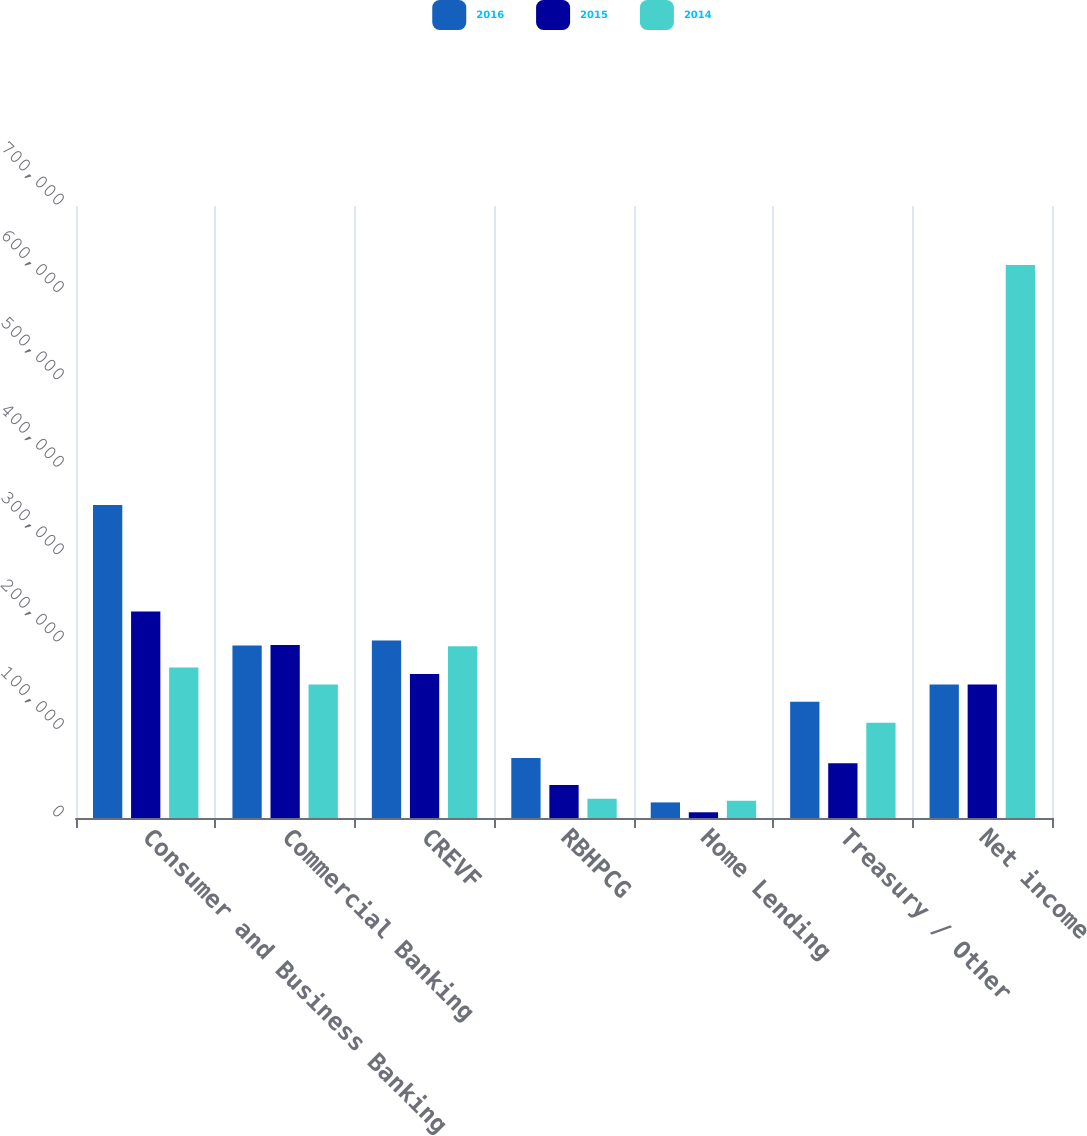Convert chart to OTSL. <chart><loc_0><loc_0><loc_500><loc_500><stacked_bar_chart><ecel><fcel>Consumer and Business Banking<fcel>Commercial Banking<fcel>CREVF<fcel>RBHPCG<fcel>Home Lending<fcel>Treasury / Other<fcel>Net income<nl><fcel>2016<fcel>358146<fcel>197375<fcel>203029<fcel>68504<fcel>17837<fcel>133070<fcel>152653<nl><fcel>2015<fcel>236298<fcel>198008<fcel>164830<fcel>37861<fcel>6561<fcel>62521<fcel>152653<nl><fcel>2014<fcel>172199<fcel>152653<fcel>196377<fcel>22010<fcel>19727<fcel>108880<fcel>632392<nl></chart> 